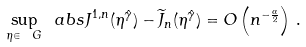<formula> <loc_0><loc_0><loc_500><loc_500>\sup _ { \eta \in \ G } \ a b s { J ^ { 1 , n } ( \eta ^ { \hat { \gamma } } ) - \widetilde { J } _ { n } ( \eta ^ { \hat { \gamma } } ) } = O \left ( n ^ { - \frac { \alpha } { 2 } } \right ) \, .</formula> 